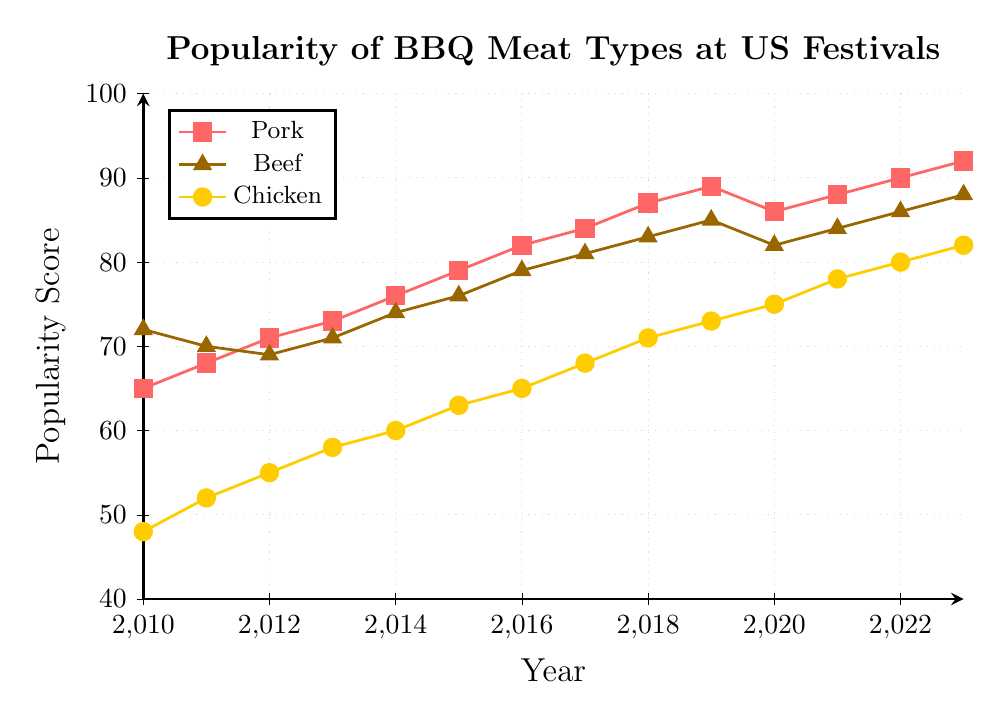Which meat type had the highest popularity in 2010? By looking at the figure at the year 2010, compare the popularity scores for pork, beef, and chicken. Beef has a score of 72, which is higher than both pork (65) and chicken (48).
Answer: Beef Between 2010 and 2023, which meat type showed the biggest increase in popularity? Calculate the difference in popularity scores from 2010 to 2023 for each meat. Pork increased from 65 to 92 (27 points), beef from 72 to 88 (16 points), and chicken from 48 to 82 (34 points). Chicken has the largest increase.
Answer: Chicken In 2014, how much more popular was beef compared to chicken? Identify the popularity scores in 2014: beef (74) and chicken (60). Subtract chicken’s score from beef’s score: 74 - 60 = 14.
Answer: 14 Which year did pork first surpass a popularity score of 80? Check the year-by-year scores for pork: it surpasses 80 between 2015 (79) and 2016 (82). The year to consider is 2016.
Answer: 2016 Did any meat type decrease in popularity from one year to the next? If so, which years? Examine the year-by-year scores for each meat from 2010 to 2023. Pork decreases from 2019 (89) to 2020 (86). Beef decreases from 2019 (85) to 2020 (82). There are no decreases for chicken.
Answer: 2019 to 2020 for pork and beef What's the average popularity score for chicken from 2010 to 2023? Sum the scores for chicken from 2010 to 2023: (48 + 52 + 55 + 58 + 60 + 63 + 65 + 68 + 71 + 73 + 75 + 78 + 80 + 82) = 930. Divide by the number of years: 930 / 14 ≈ 66.43.
Answer: 66.43 Which meat type had the most consistent increase in popularity over the years? Identify the score trendlines for each meat from the figure. Chicken consistently increases every year without any drops, making it the most consistent.
Answer: Chicken In what year did pork's popularity score surpass the beef score for the first time? Compare year-by-year scores of pork and beef: pork first surpasses beef between 2011 (pork 71 and beef 69) and 2012. Pork surpasses beef again in 2020.
Answer: 2012 and 2020 Which meat type had the highest popularity score in the final year (2023)? Review the final year data: pork (92), beef (88), and chicken (82). Pork has the highest score among the three.
Answer: Pork 